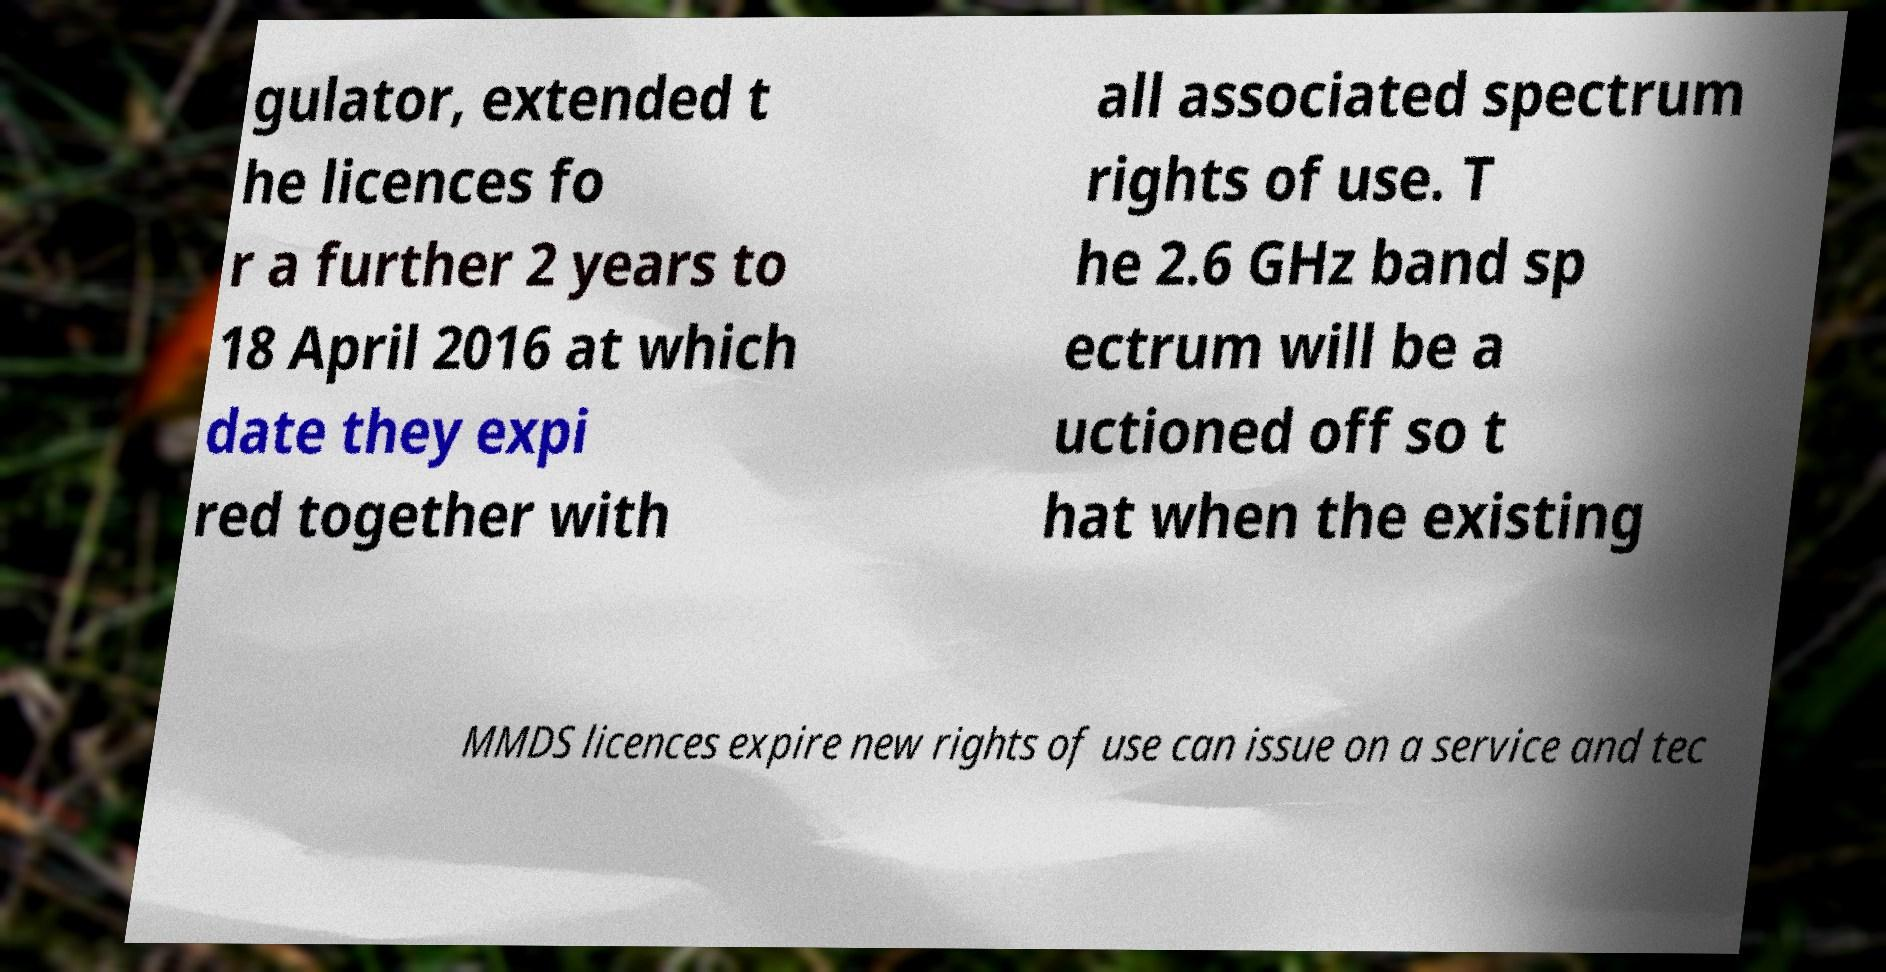What messages or text are displayed in this image? I need them in a readable, typed format. gulator, extended t he licences fo r a further 2 years to 18 April 2016 at which date they expi red together with all associated spectrum rights of use. T he 2.6 GHz band sp ectrum will be a uctioned off so t hat when the existing MMDS licences expire new rights of use can issue on a service and tec 